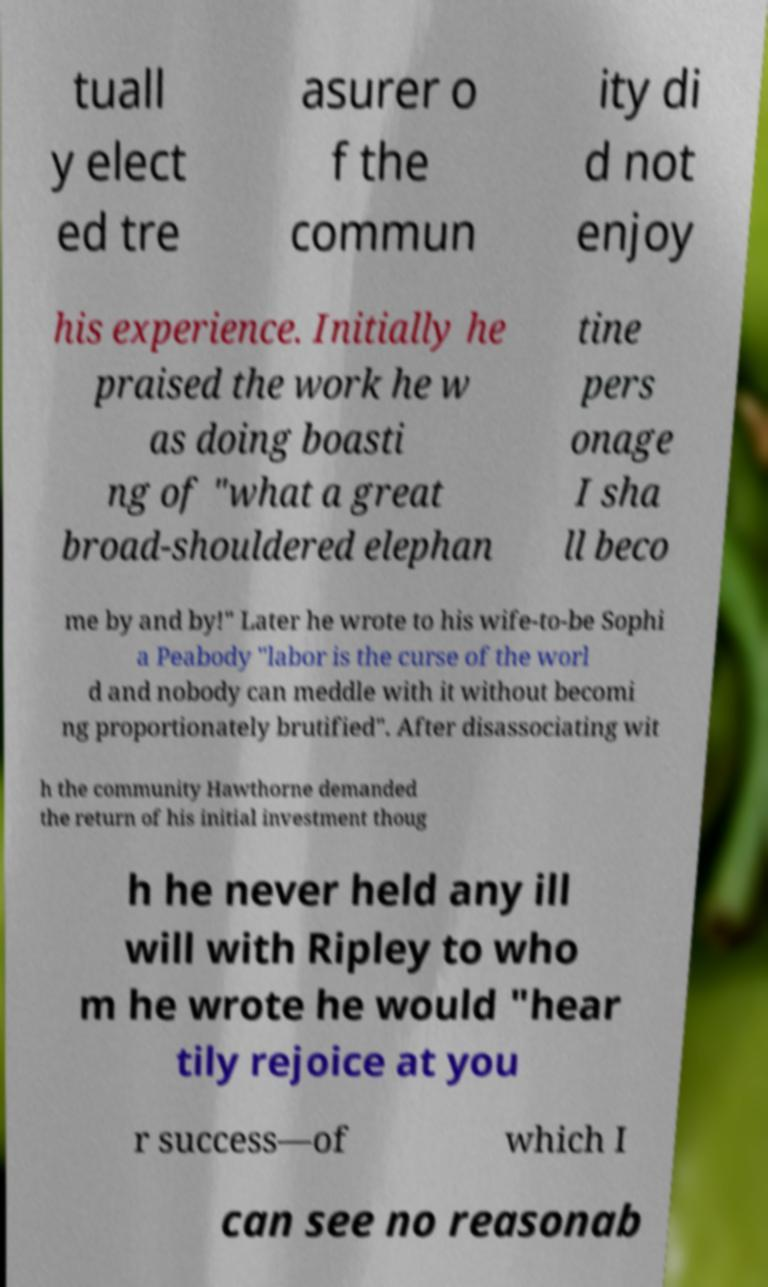Please identify and transcribe the text found in this image. tuall y elect ed tre asurer o f the commun ity di d not enjoy his experience. Initially he praised the work he w as doing boasti ng of "what a great broad-shouldered elephan tine pers onage I sha ll beco me by and by!" Later he wrote to his wife-to-be Sophi a Peabody "labor is the curse of the worl d and nobody can meddle with it without becomi ng proportionately brutified". After disassociating wit h the community Hawthorne demanded the return of his initial investment thoug h he never held any ill will with Ripley to who m he wrote he would "hear tily rejoice at you r success—of which I can see no reasonab 